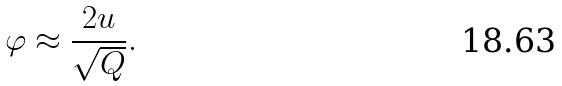<formula> <loc_0><loc_0><loc_500><loc_500>\varphi \approx \frac { 2 u } { \sqrt { Q } } .</formula> 